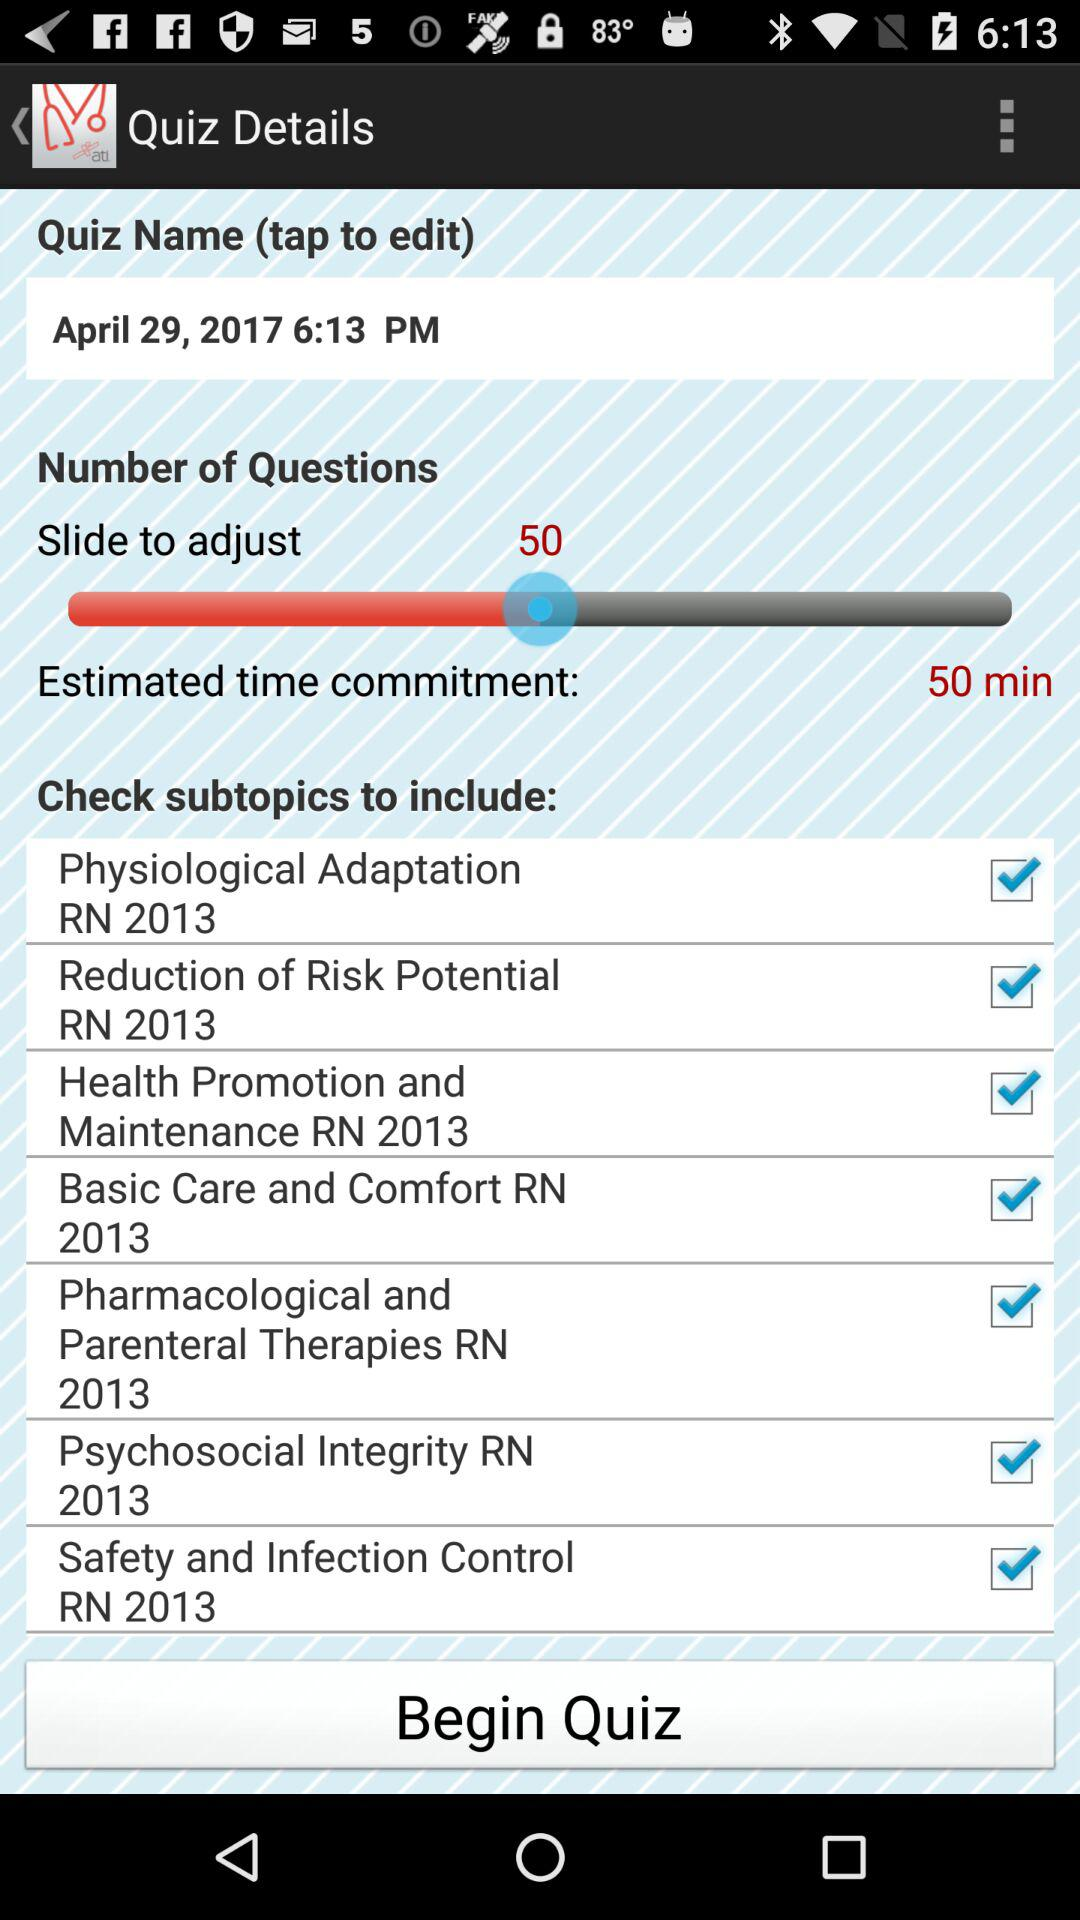Which version of the application is this?
When the provided information is insufficient, respond with <no answer>. <no answer> 